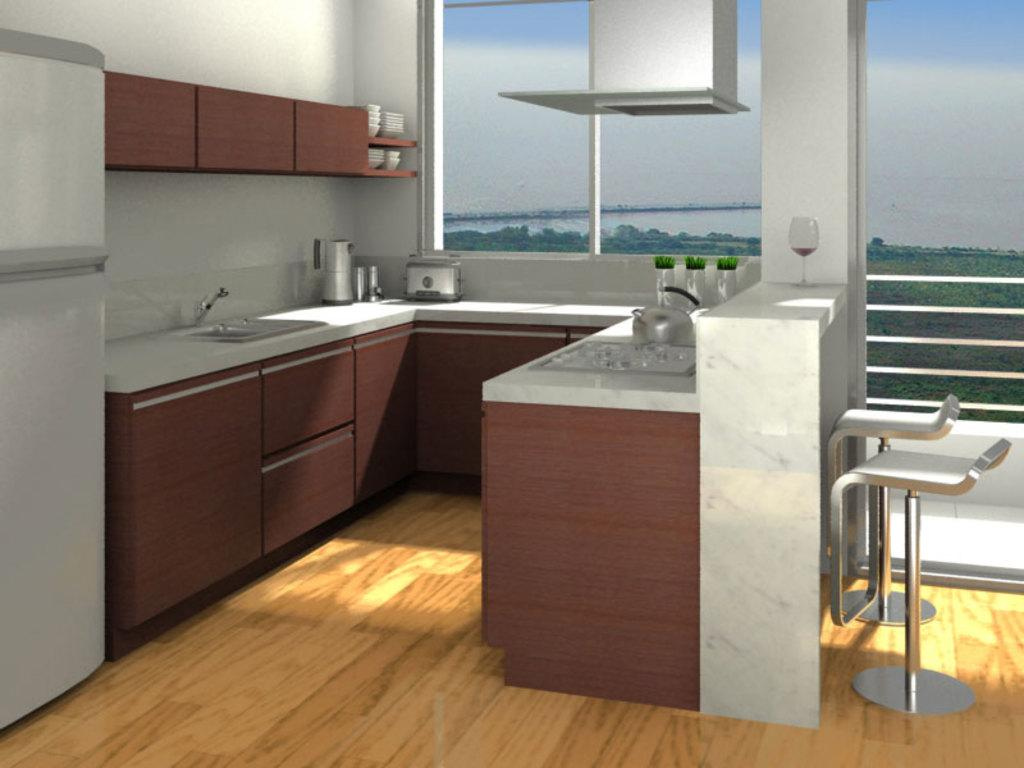What type of setting is shown in the image? The image depicts an inside view of a room. What can be found in the room for holding liquids? There are cups in the room. What is a source of water in the room? There is a tap in the room. What appliance is present for storing food and drinks? There is a refrigerator in the room. What surface might be used for preparing or storing items in the room? There are items on the countertop. What type of furniture is present for seating in the room? There are chairs in the room. What type of flowers can be seen growing on the arch in the room? There is no arch or flowers present in the room; the image shows an inside view of a room with the mentioned objects and features. 